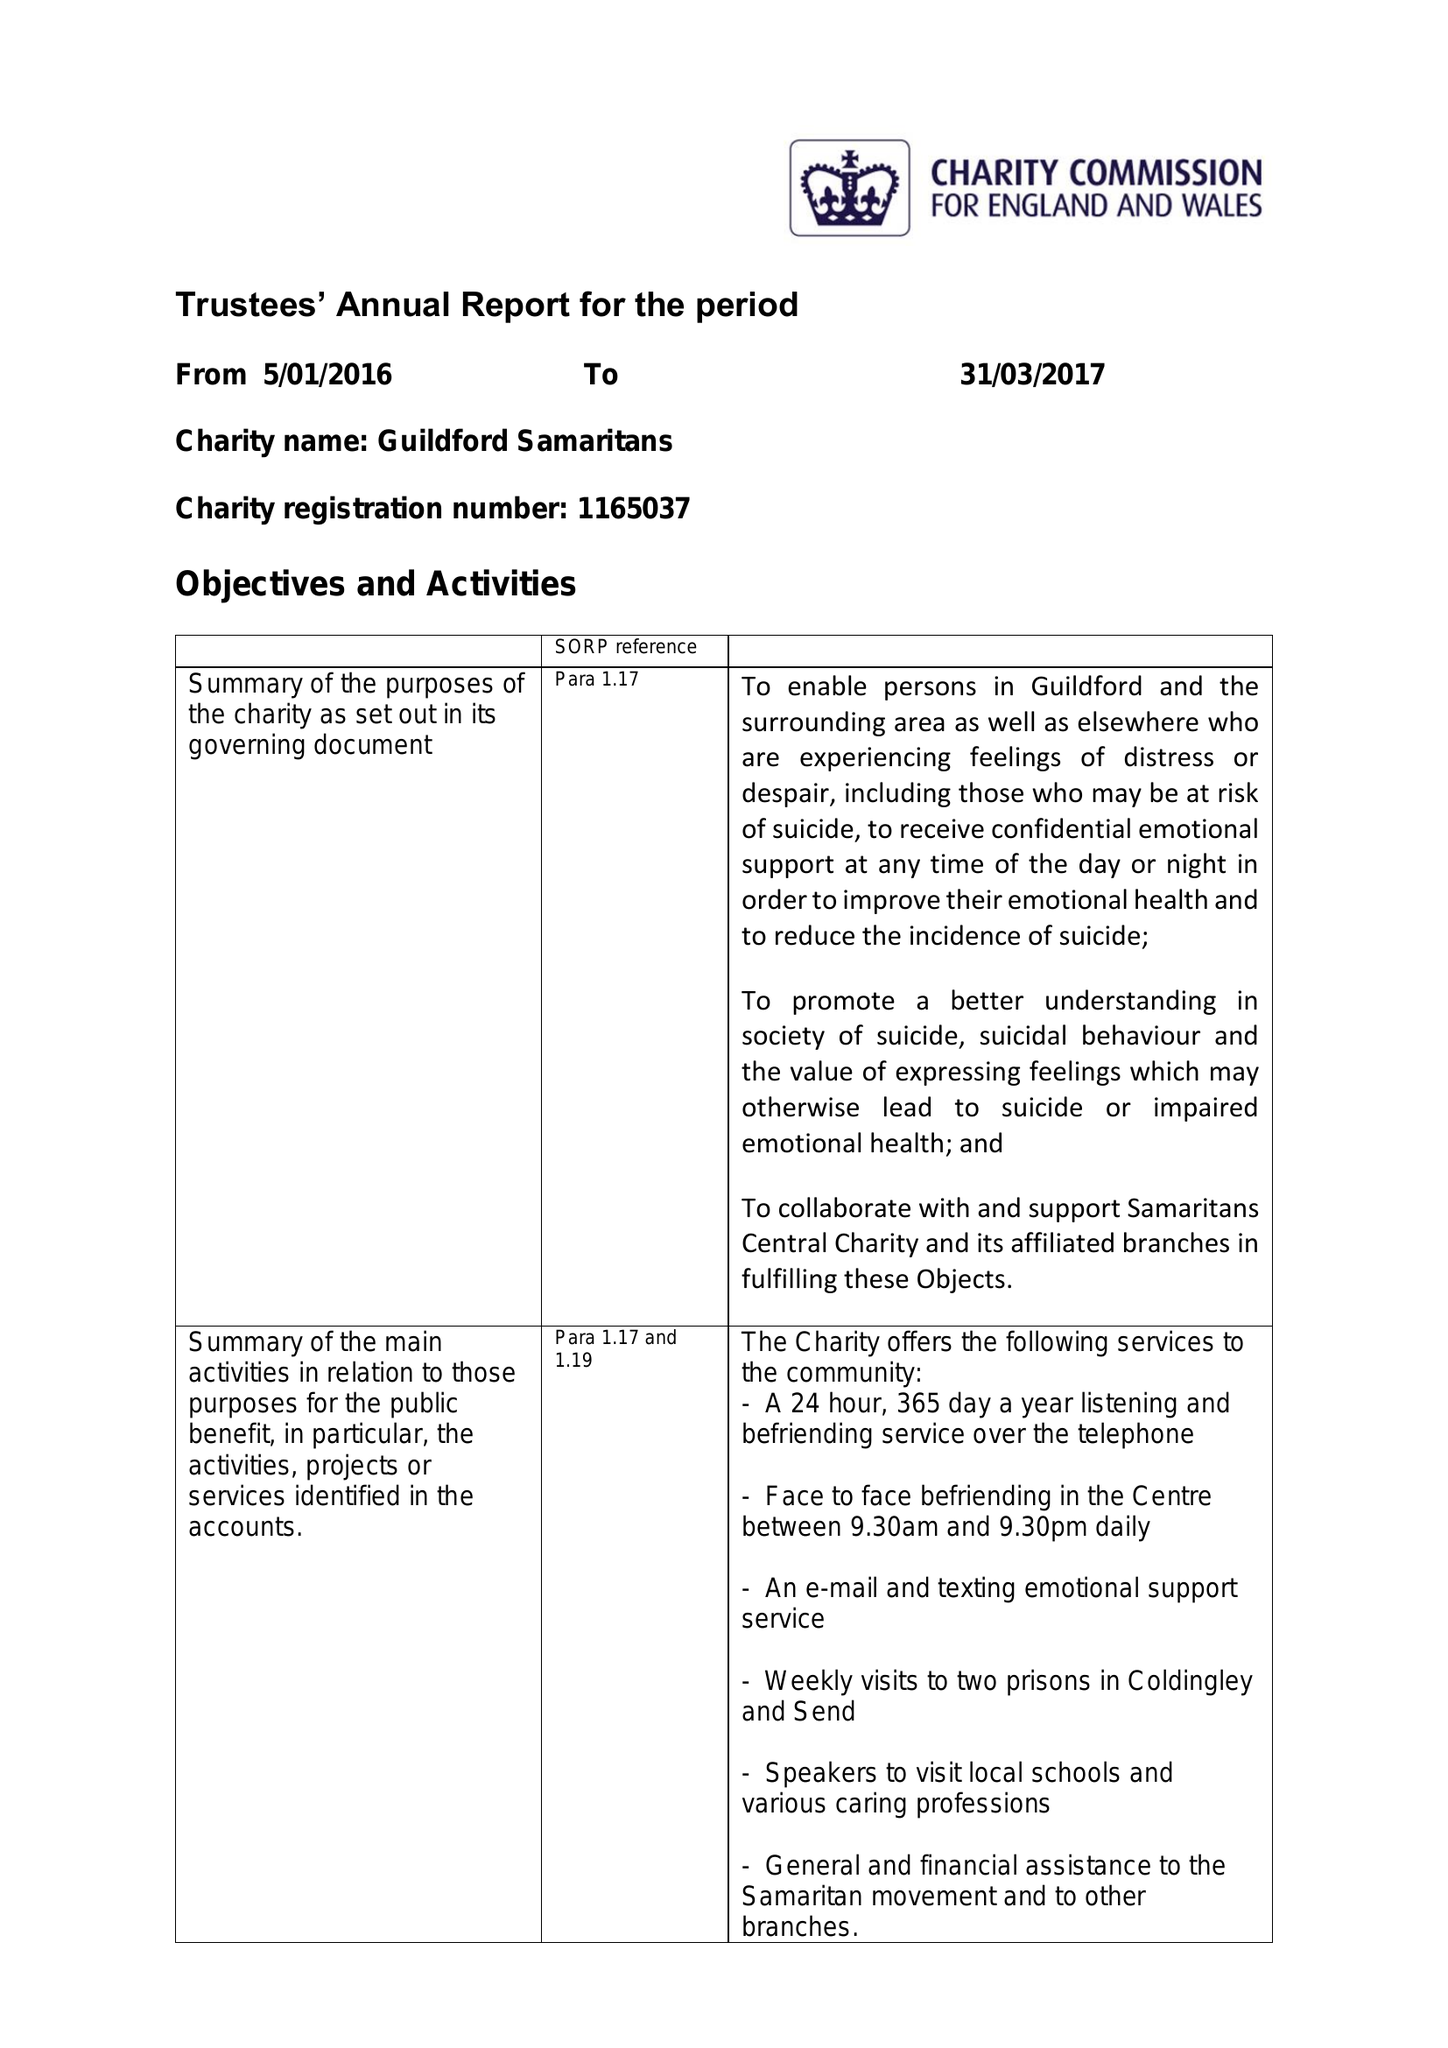What is the value for the address__post_town?
Answer the question using a single word or phrase. GUILDFORD 